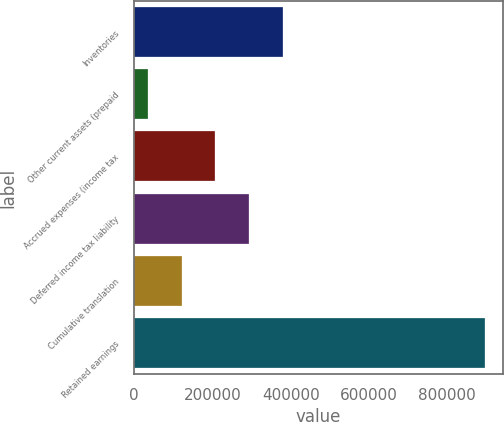<chart> <loc_0><loc_0><loc_500><loc_500><bar_chart><fcel>Inventories<fcel>Other current assets (prepaid<fcel>Accrued expenses (income tax<fcel>Deferred income tax liability<fcel>Cumulative translation<fcel>Retained earnings<nl><fcel>380118<fcel>35545<fcel>207831<fcel>293975<fcel>121688<fcel>896977<nl></chart> 